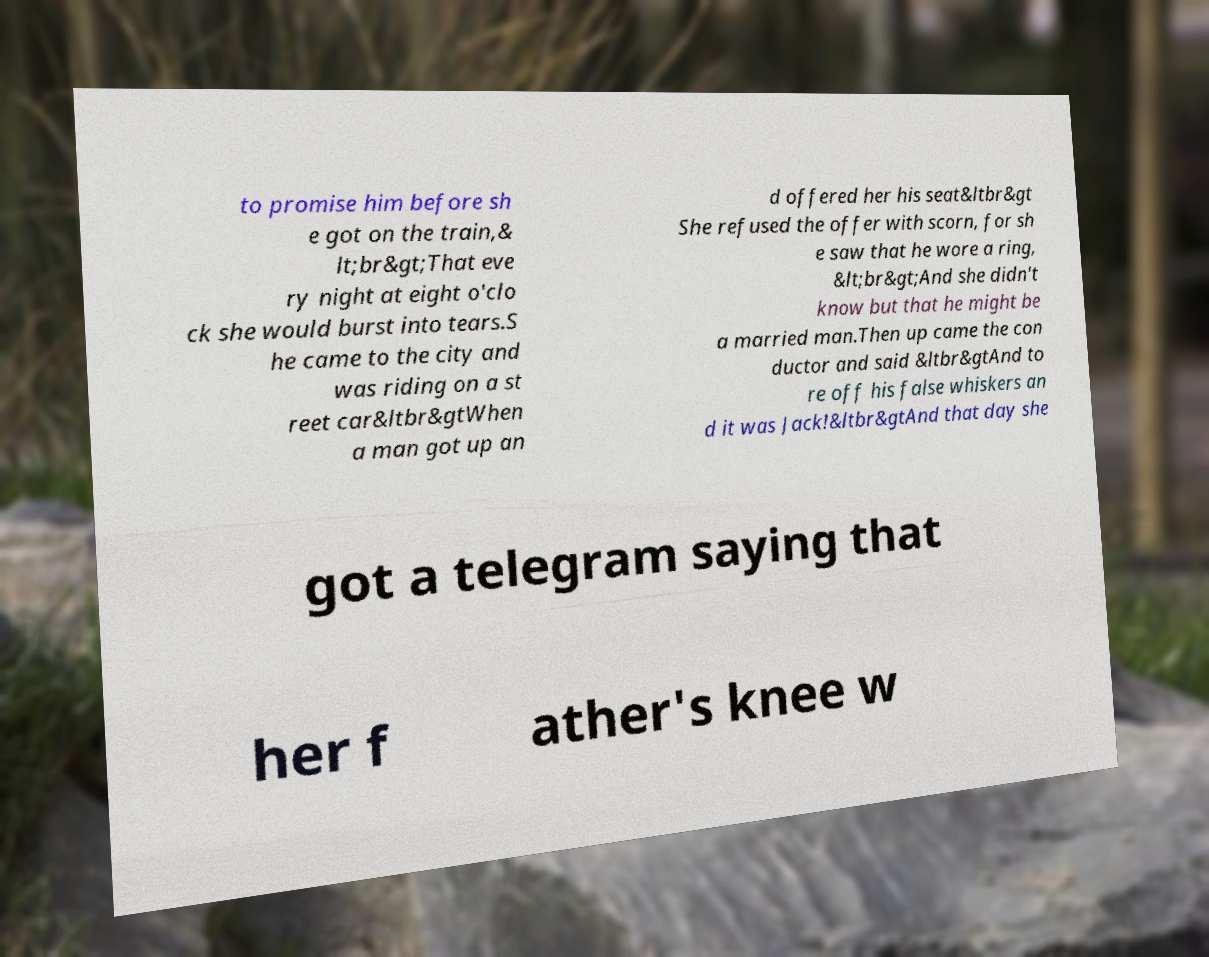Can you read and provide the text displayed in the image?This photo seems to have some interesting text. Can you extract and type it out for me? to promise him before sh e got on the train,& lt;br&gt;That eve ry night at eight o'clo ck she would burst into tears.S he came to the city and was riding on a st reet car&ltbr&gtWhen a man got up an d offered her his seat&ltbr&gt She refused the offer with scorn, for sh e saw that he wore a ring, &lt;br&gt;And she didn't know but that he might be a married man.Then up came the con ductor and said &ltbr&gtAnd to re off his false whiskers an d it was Jack!&ltbr&gtAnd that day she got a telegram saying that her f ather's knee w 